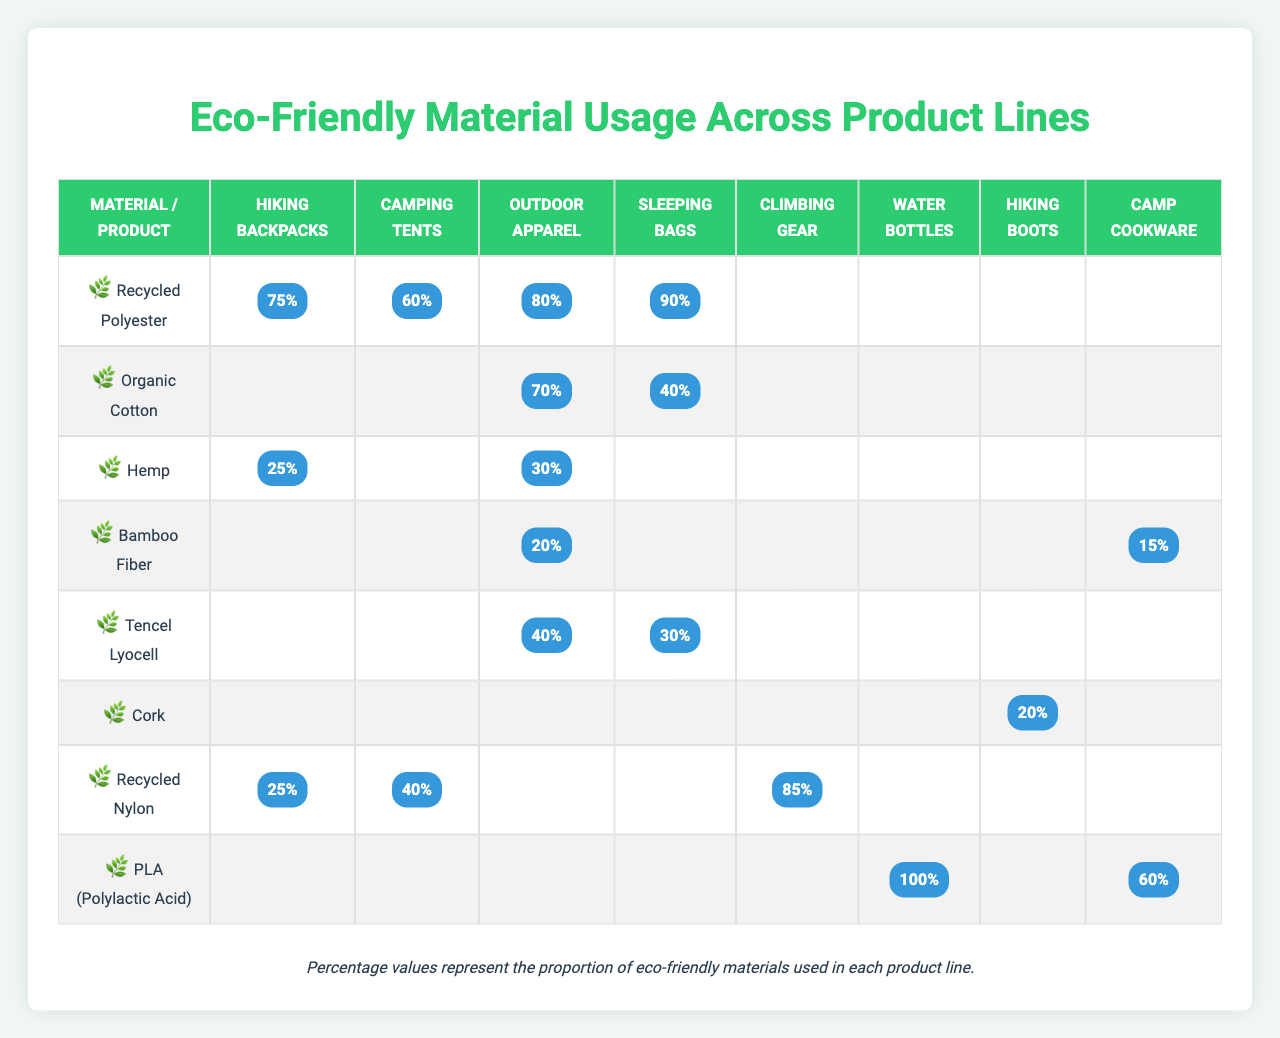What is the highest usage percentage of Recycled Polyester across any product line? The highest usage percentage of Recycled Polyester is 90%, which is used in Sleeping Bags.
Answer: 90% Which product line uses the least amount of Organic Cotton? Organic Cotton is used the least in Sleeping Bags, with a usage percentage of only 40%.
Answer: 40% Which product uses 100% of PLA (Polylactic Acid)? Water Bottles use 100% of PLA (Polylactic Acid).
Answer: Yes What percentage of materials used in Camping Tents is made up of Recycled Polyester and Recycled Nylon combined? The usage of Recycled Polyester in Camping Tents is 60% and Recycled Nylon is 40%. Adding these percentages together gives 60% + 40% = 100%.
Answer: 100% Is Bamboo Fiber used in more than two product lines? Bamboo Fiber is only used in two product lines: Outdoor Apparel and Camp Cookware.
Answer: No Which eco-friendly material has the highest usage percentage in Outdoor Apparel? In Outdoor Apparel, the material with the highest usage percentage is Recycled Polyester at 80%.
Answer: 80% What is the total percentage of materials used in Hiking Backpacks from Recycled Polyester and Hemp? The percentage of Recycled Polyester in Hiking Backpacks is 75% and Hemp is 25%. Adding these together gives 75% + 25% = 100%.
Answer: 100% Which product line has the lowest usage percentage of Tencel Lyocell? Tencel Lyocell has a usage percentage of 30% in Sleeping Bags, which is the lowest among the listed product lines.
Answer: 30% What eco-friendly material is used exclusively for Water Bottles? The eco-friendly material used exclusively for Water Bottles is PLA (Polylactic Acid).
Answer: PLA (Polylactic Acid) How does the percentage of Recycled Nylon in Climbing Gear compare to that in Camping Tents? The usage percentage of Recycled Nylon in Climbing Gear is 85%, while in Camping Tents it is 40%. So, 85% - 40% = 45% more is used in Climbing Gear.
Answer: 45% more Which product line has the highest overall usage of eco-friendly materials? The highest overall usage of eco-friendly materials is in Sleeping Bags, where Recycled Polyester, Organic Cotton, and Tencel Lyocell contribute to a total of 90%, 40%, and 30% respectively. Summing these gives 90% + 40% + 30% = 160%.
Answer: 160% 